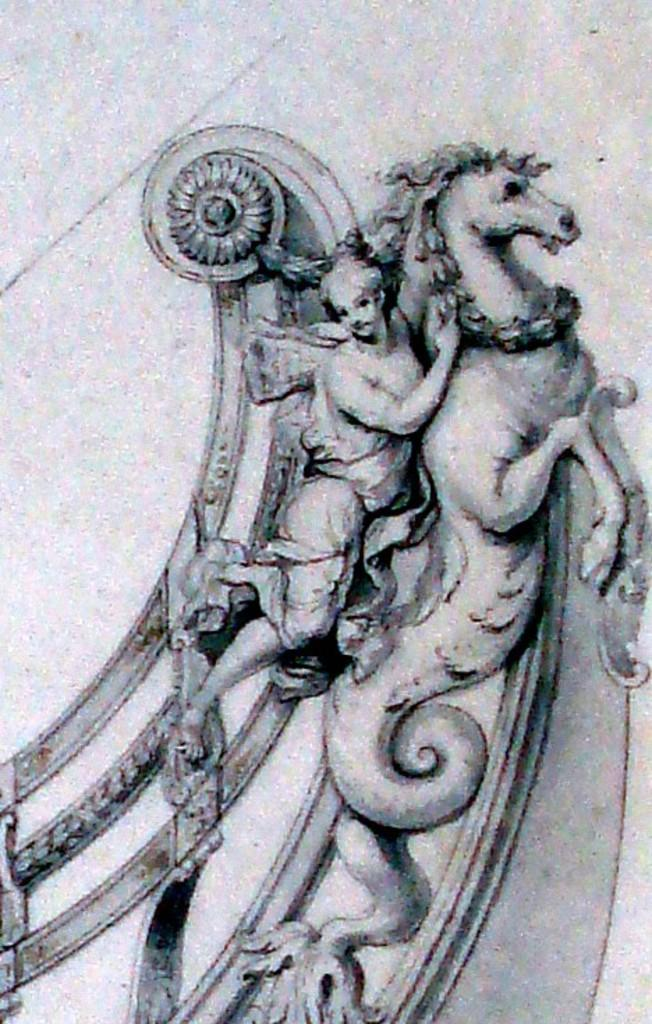What is the main subject in the center of the image? There is a paper in the center of the image. What is depicted on the paper? The paper contains a painting. How many people are featured in the painting? The painting features one person. How many horses are featured in the painting? The painting features one horse. What other objects are included in the painting? The painting includes a few other objects. Where is the hydrant located in the painting? There is no hydrant present in the painting. How can the person in the painting be helped? The painting is a static image and does not depict any situation requiring help. 